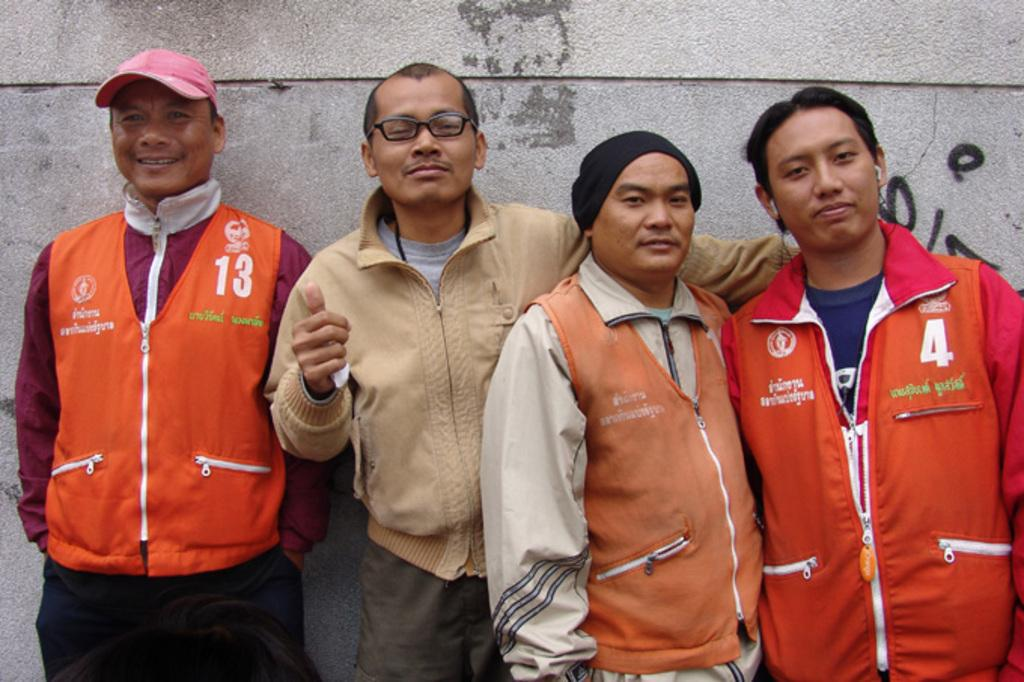<image>
Provide a brief description of the given image. four guys posing for a photo, one is waring a vest with 123 on it and another guy has number 4 on his jacket 